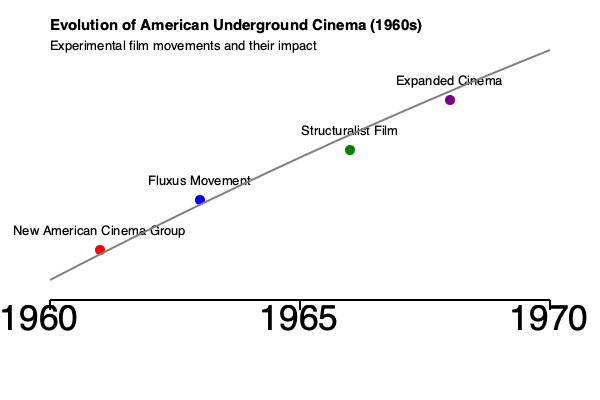Based on the timeline graphic, which movement appears to have had the most significant impact on the evolution of American underground cinema in the mid-1960s, and how does this align with the overall trend shown? To answer this question, we need to analyze the timeline graphic step-by-step:

1. The timeline spans from 1960 to 1970, with key events marked along the way.

2. The y-axis represents the impact or significance of each movement, with higher positions indicating greater influence.

3. Four major movements are highlighted:
   - New American Cinema Group (early 1960s)
   - Fluxus Movement (early to mid-1960s)
   - Structuralist Film (mid-1960s)
   - Expanded Cinema (late 1960s)

4. The gray trend line shows an overall increase in the impact and complexity of underground cinema throughout the decade.

5. In the mid-1960s (around 1965), the Structuralist Film movement is positioned highest on the y-axis for that time period.

6. The Structuralist Film movement aligns closely with the upward trajectory of the trend line, suggesting it played a significant role in the evolution of underground cinema at that time.

7. While Expanded Cinema is shown to have an even higher impact, it occurs later in the decade and doesn't align with the "mid-1960s" timeframe specified in the question.

Therefore, based on its position on the timeline and alignment with the overall trend, the Structuralist Film movement appears to have had the most significant impact on the evolution of American underground cinema in the mid-1960s.
Answer: Structuralist Film 